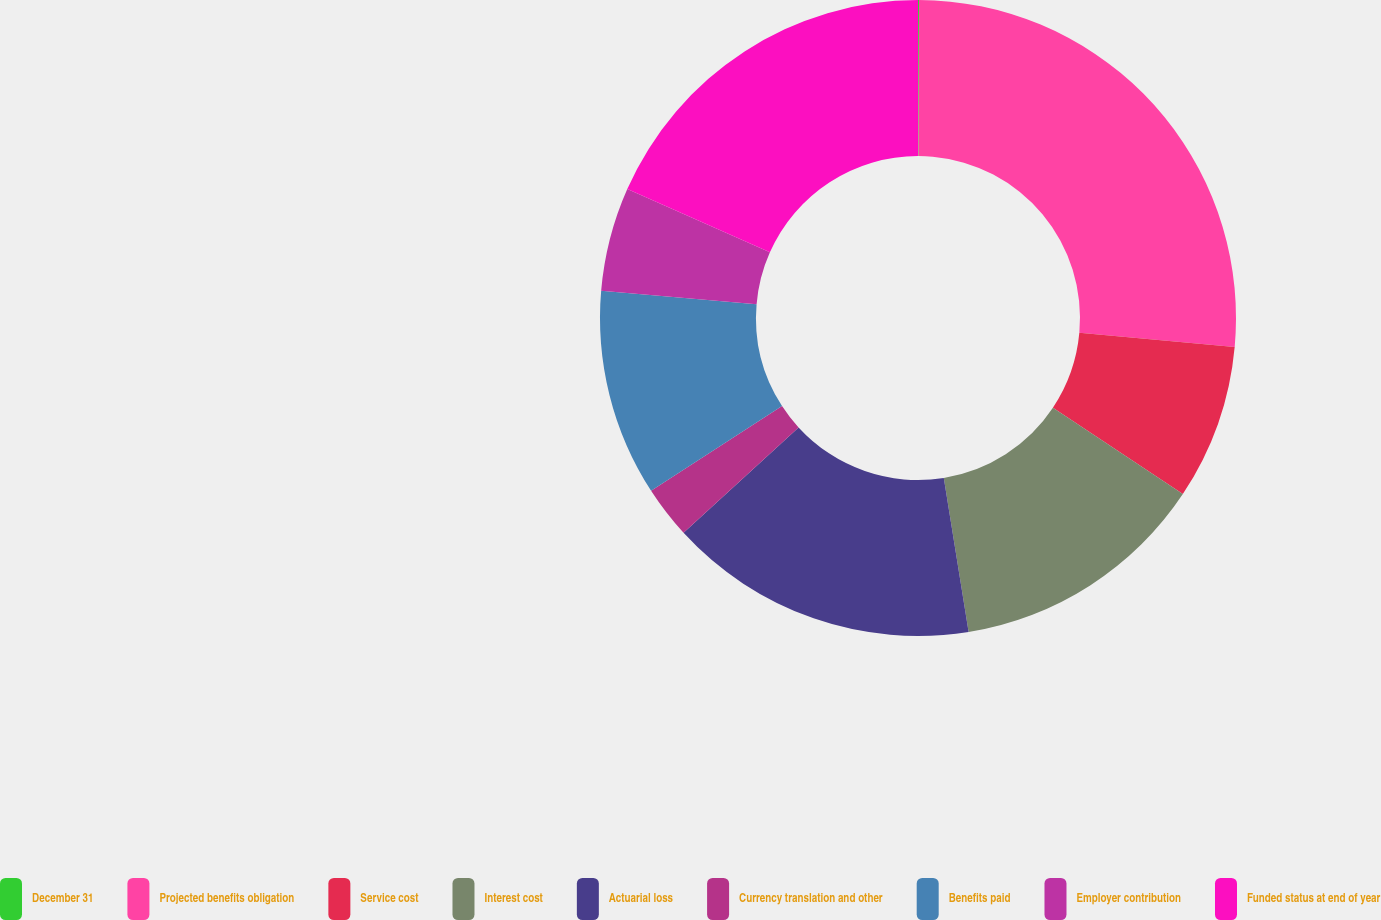<chart> <loc_0><loc_0><loc_500><loc_500><pie_chart><fcel>December 31<fcel>Projected benefits obligation<fcel>Service cost<fcel>Interest cost<fcel>Actuarial loss<fcel>Currency translation and other<fcel>Benefits paid<fcel>Employer contribution<fcel>Funded status at end of year<nl><fcel>0.05%<fcel>26.4%<fcel>7.89%<fcel>13.12%<fcel>15.74%<fcel>2.66%<fcel>10.51%<fcel>5.28%<fcel>18.36%<nl></chart> 